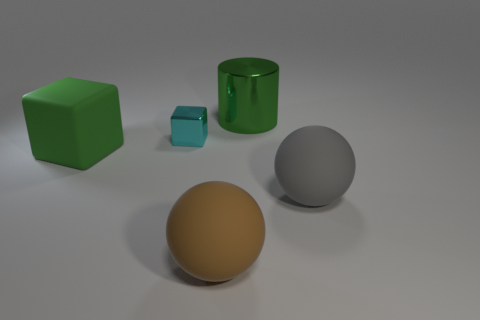Add 3 big gray things. How many objects exist? 8 Subtract all cylinders. How many objects are left? 4 Subtract 0 brown cylinders. How many objects are left? 5 Subtract 1 balls. How many balls are left? 1 Subtract all red cubes. Subtract all green cylinders. How many cubes are left? 2 Subtract all cyan blocks. How many cyan cylinders are left? 0 Subtract all big red metal cylinders. Subtract all big spheres. How many objects are left? 3 Add 4 small cyan things. How many small cyan things are left? 5 Add 3 small cyan spheres. How many small cyan spheres exist? 3 